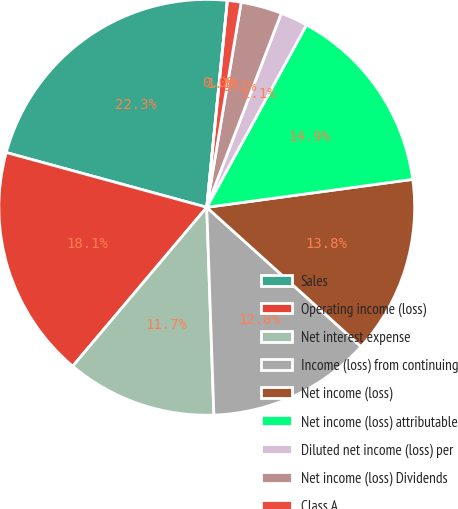Convert chart. <chart><loc_0><loc_0><loc_500><loc_500><pie_chart><fcel>Sales<fcel>Operating income (loss)<fcel>Net interest expense<fcel>Income (loss) from continuing<fcel>Net income (loss)<fcel>Net income (loss) attributable<fcel>Diluted net income (loss) per<fcel>Net income (loss) Dividends<fcel>Class A<fcel>Class B<nl><fcel>22.34%<fcel>18.09%<fcel>11.7%<fcel>12.77%<fcel>13.83%<fcel>14.89%<fcel>2.13%<fcel>3.19%<fcel>1.06%<fcel>0.0%<nl></chart> 